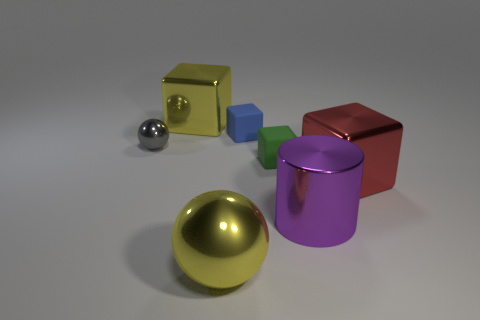Add 2 purple objects. How many objects exist? 9 Subtract all big red shiny cubes. How many cubes are left? 3 Subtract all red cubes. How many cubes are left? 3 Subtract all cubes. How many objects are left? 3 Subtract 0 blue cylinders. How many objects are left? 7 Subtract 1 balls. How many balls are left? 1 Subtract all red cylinders. Subtract all purple spheres. How many cylinders are left? 1 Subtract all cyan blocks. How many gray balls are left? 1 Subtract all tiny cubes. Subtract all tiny gray objects. How many objects are left? 4 Add 3 large shiny things. How many large shiny things are left? 7 